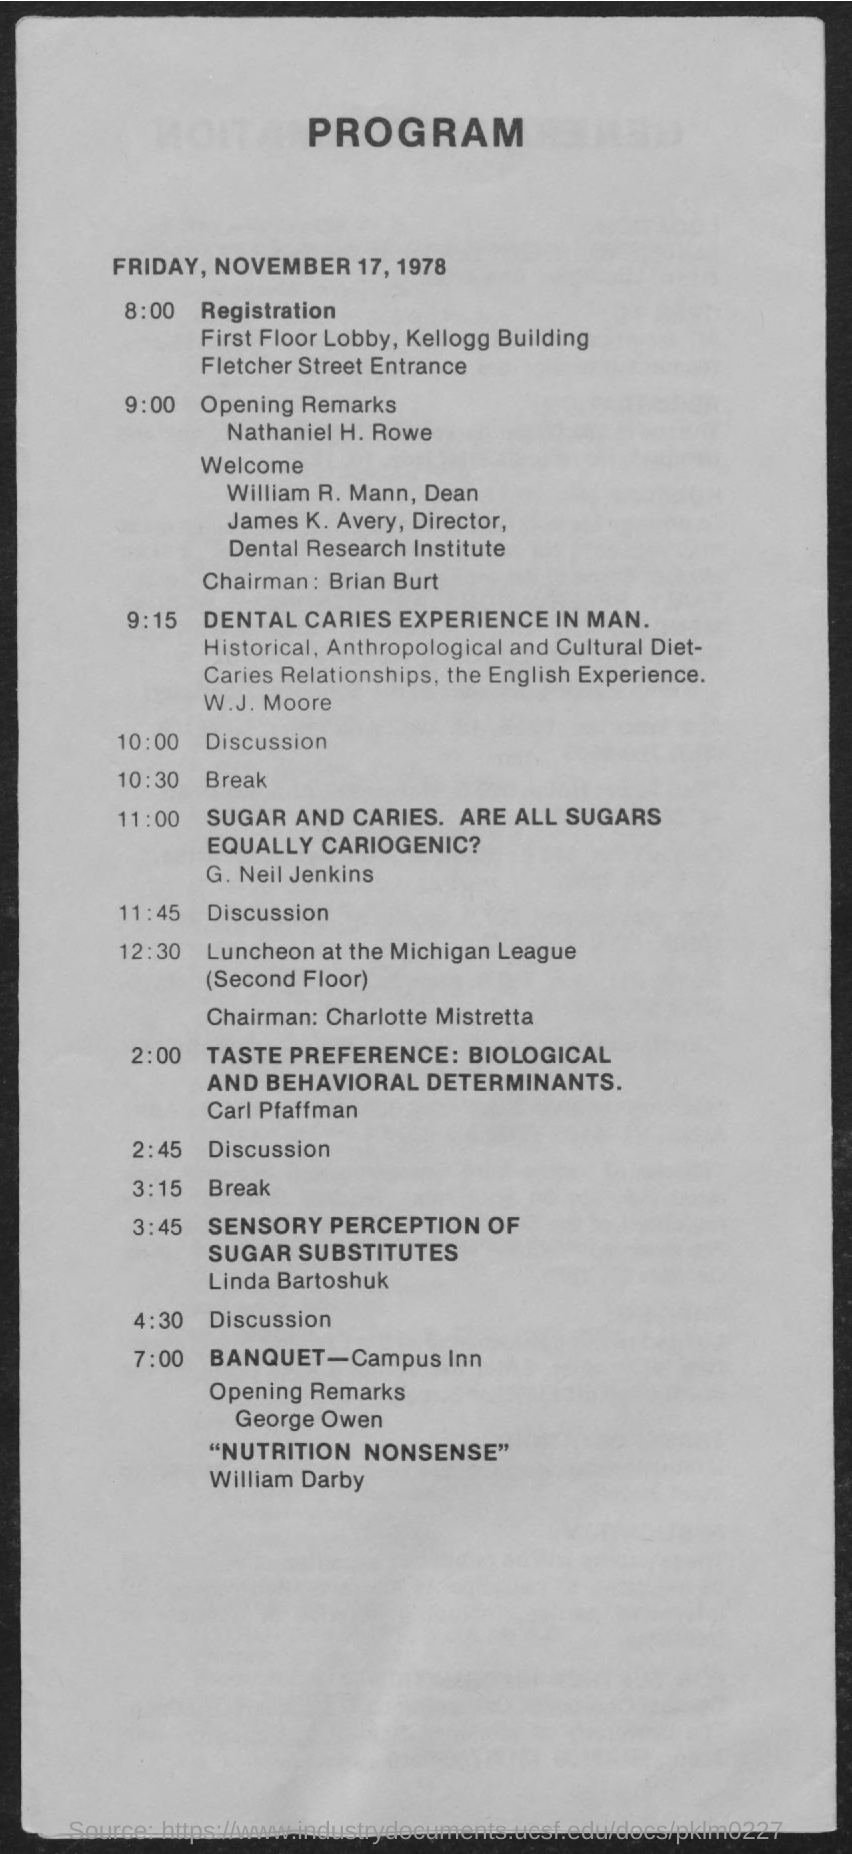Specify some key components in this picture. FRIDAY, NOVEMBER 17, 1978, is the date on the document. The registration will take place at 8:00 AM. 